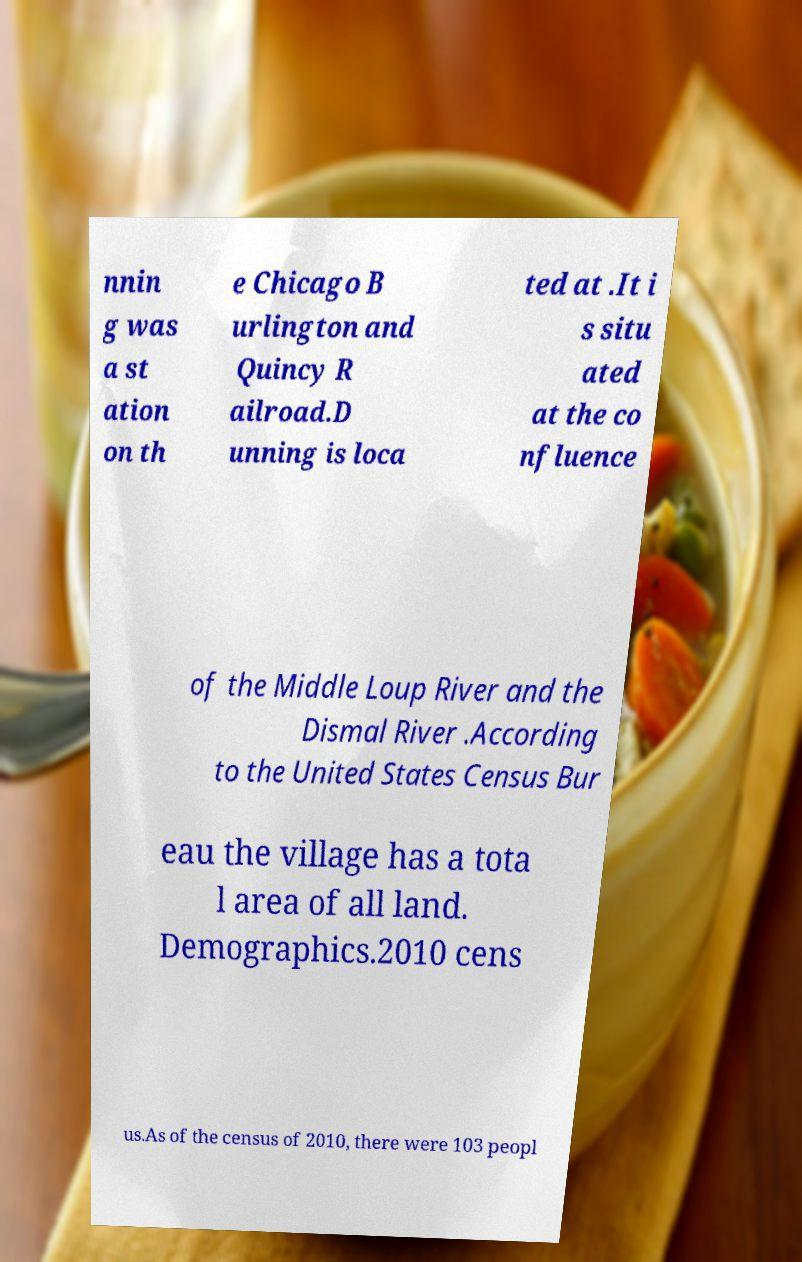Can you read and provide the text displayed in the image?This photo seems to have some interesting text. Can you extract and type it out for me? nnin g was a st ation on th e Chicago B urlington and Quincy R ailroad.D unning is loca ted at .It i s situ ated at the co nfluence of the Middle Loup River and the Dismal River .According to the United States Census Bur eau the village has a tota l area of all land. Demographics.2010 cens us.As of the census of 2010, there were 103 peopl 